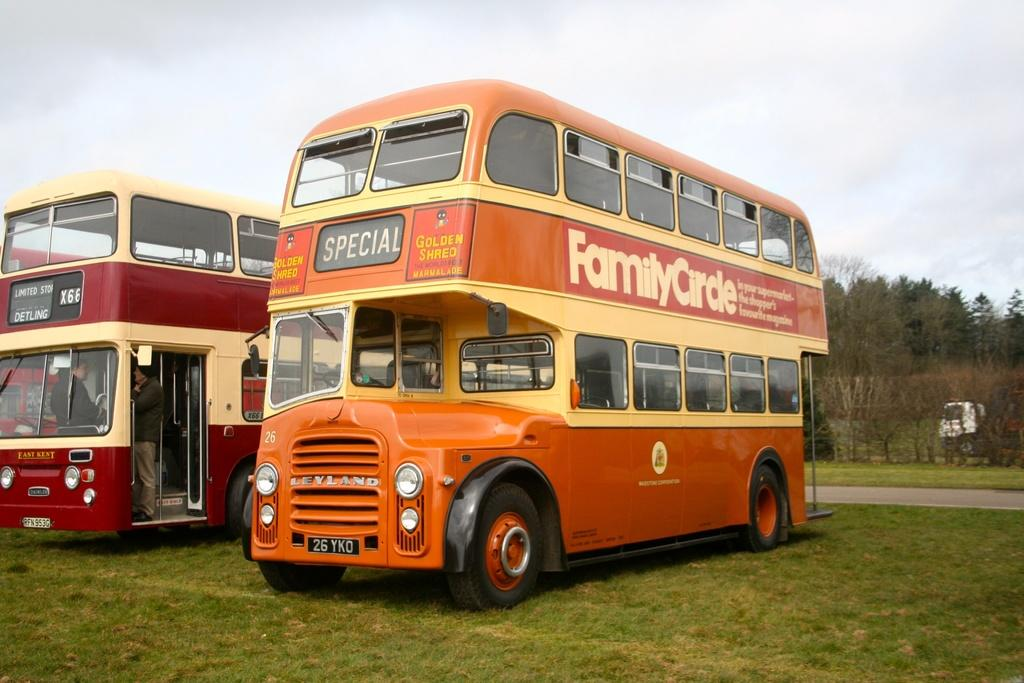<image>
Write a terse but informative summary of the picture. A yellow double decker bus has Family Circle written on the side. 